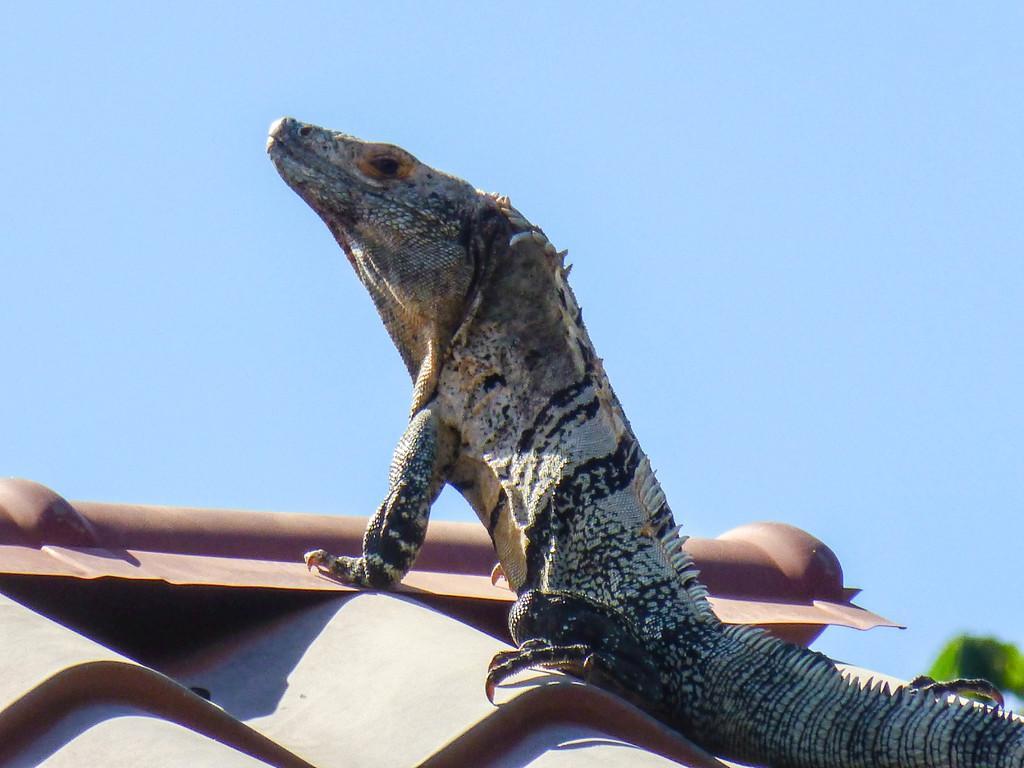Please provide a concise description of this image. In this picture we can see a lizard on a rooftop and in the background we can see the sky. 